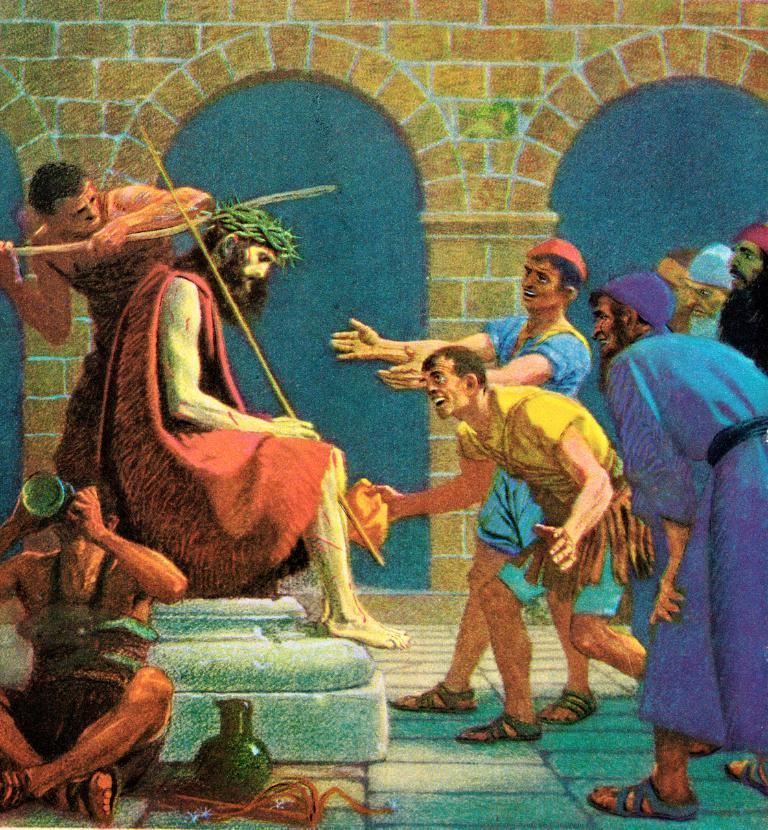Please provide a concise description of this image. In this image I can see the depiction picture, where I see number of people and I see 2 of them are sitting and rest of them are standing. In the background I can see the pillars and the wall. In the front of this picture I can see a pot and I see a person, holding a thing near to his mouth. 